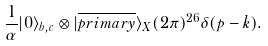<formula> <loc_0><loc_0><loc_500><loc_500>\frac { 1 } { \alpha } | 0 \rangle _ { b , c } \otimes | \overline { p r i m a r y } \rangle _ { X } ( 2 \pi ) ^ { 2 6 } \delta ( p - k ) .</formula> 